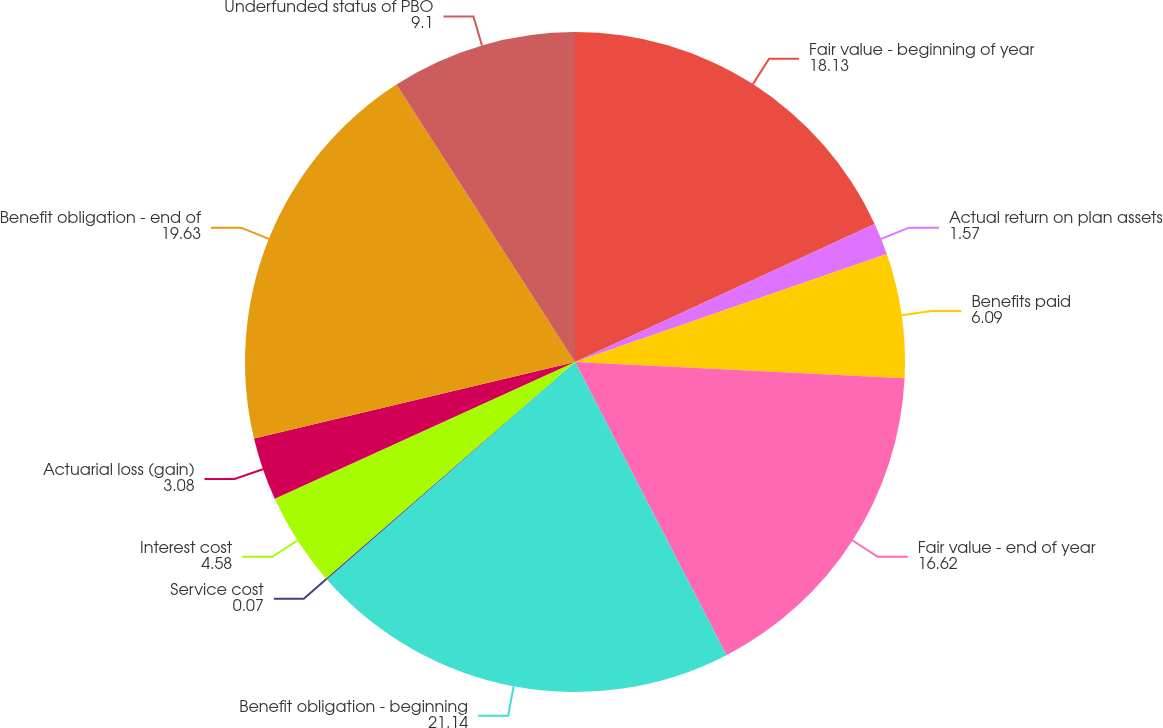Convert chart. <chart><loc_0><loc_0><loc_500><loc_500><pie_chart><fcel>Fair value - beginning of year<fcel>Actual return on plan assets<fcel>Benefits paid<fcel>Fair value - end of year<fcel>Benefit obligation - beginning<fcel>Service cost<fcel>Interest cost<fcel>Actuarial loss (gain)<fcel>Benefit obligation - end of<fcel>Underfunded status of PBO<nl><fcel>18.13%<fcel>1.57%<fcel>6.09%<fcel>16.62%<fcel>21.14%<fcel>0.07%<fcel>4.58%<fcel>3.08%<fcel>19.63%<fcel>9.1%<nl></chart> 